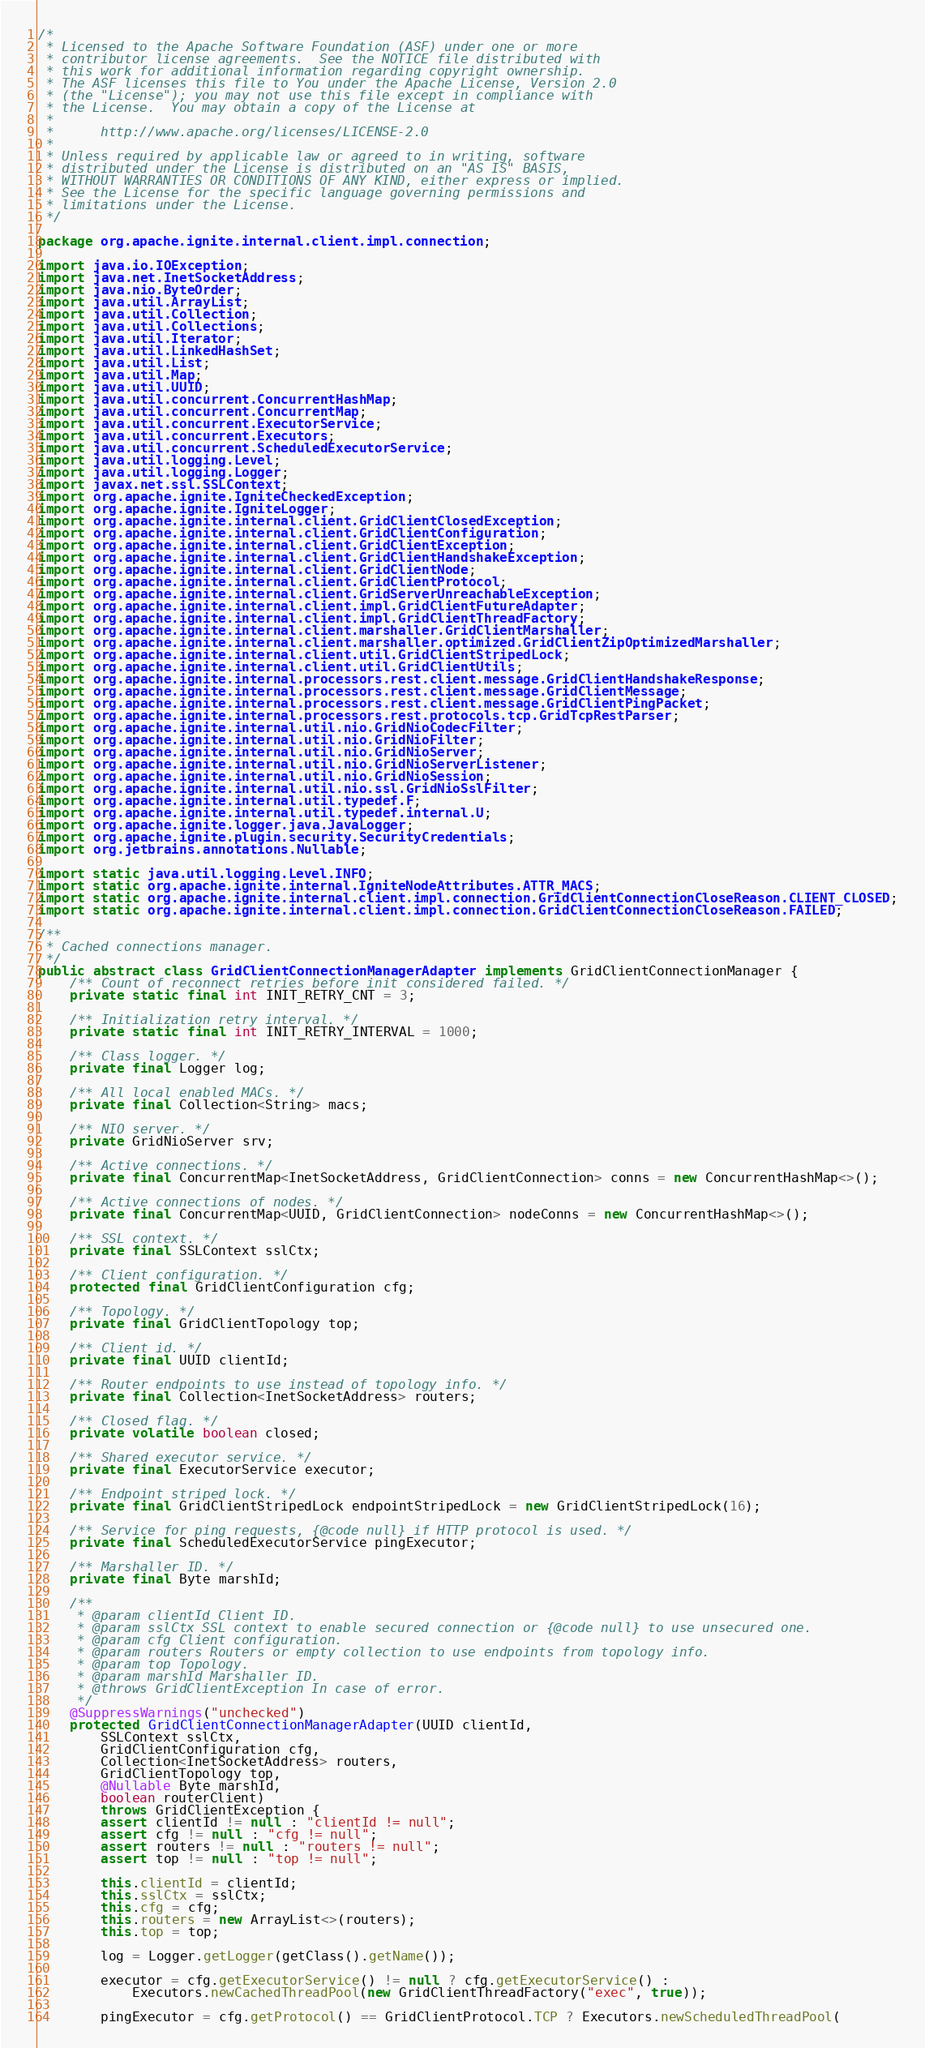<code> <loc_0><loc_0><loc_500><loc_500><_Java_>/*
 * Licensed to the Apache Software Foundation (ASF) under one or more
 * contributor license agreements.  See the NOTICE file distributed with
 * this work for additional information regarding copyright ownership.
 * The ASF licenses this file to You under the Apache License, Version 2.0
 * (the "License"); you may not use this file except in compliance with
 * the License.  You may obtain a copy of the License at
 *
 *      http://www.apache.org/licenses/LICENSE-2.0
 *
 * Unless required by applicable law or agreed to in writing, software
 * distributed under the License is distributed on an "AS IS" BASIS,
 * WITHOUT WARRANTIES OR CONDITIONS OF ANY KIND, either express or implied.
 * See the License for the specific language governing permissions and
 * limitations under the License.
 */

package org.apache.ignite.internal.client.impl.connection;

import java.io.IOException;
import java.net.InetSocketAddress;
import java.nio.ByteOrder;
import java.util.ArrayList;
import java.util.Collection;
import java.util.Collections;
import java.util.Iterator;
import java.util.LinkedHashSet;
import java.util.List;
import java.util.Map;
import java.util.UUID;
import java.util.concurrent.ConcurrentHashMap;
import java.util.concurrent.ConcurrentMap;
import java.util.concurrent.ExecutorService;
import java.util.concurrent.Executors;
import java.util.concurrent.ScheduledExecutorService;
import java.util.logging.Level;
import java.util.logging.Logger;
import javax.net.ssl.SSLContext;
import org.apache.ignite.IgniteCheckedException;
import org.apache.ignite.IgniteLogger;
import org.apache.ignite.internal.client.GridClientClosedException;
import org.apache.ignite.internal.client.GridClientConfiguration;
import org.apache.ignite.internal.client.GridClientException;
import org.apache.ignite.internal.client.GridClientHandshakeException;
import org.apache.ignite.internal.client.GridClientNode;
import org.apache.ignite.internal.client.GridClientProtocol;
import org.apache.ignite.internal.client.GridServerUnreachableException;
import org.apache.ignite.internal.client.impl.GridClientFutureAdapter;
import org.apache.ignite.internal.client.impl.GridClientThreadFactory;
import org.apache.ignite.internal.client.marshaller.GridClientMarshaller;
import org.apache.ignite.internal.client.marshaller.optimized.GridClientZipOptimizedMarshaller;
import org.apache.ignite.internal.client.util.GridClientStripedLock;
import org.apache.ignite.internal.client.util.GridClientUtils;
import org.apache.ignite.internal.processors.rest.client.message.GridClientHandshakeResponse;
import org.apache.ignite.internal.processors.rest.client.message.GridClientMessage;
import org.apache.ignite.internal.processors.rest.client.message.GridClientPingPacket;
import org.apache.ignite.internal.processors.rest.protocols.tcp.GridTcpRestParser;
import org.apache.ignite.internal.util.nio.GridNioCodecFilter;
import org.apache.ignite.internal.util.nio.GridNioFilter;
import org.apache.ignite.internal.util.nio.GridNioServer;
import org.apache.ignite.internal.util.nio.GridNioServerListener;
import org.apache.ignite.internal.util.nio.GridNioSession;
import org.apache.ignite.internal.util.nio.ssl.GridNioSslFilter;
import org.apache.ignite.internal.util.typedef.F;
import org.apache.ignite.internal.util.typedef.internal.U;
import org.apache.ignite.logger.java.JavaLogger;
import org.apache.ignite.plugin.security.SecurityCredentials;
import org.jetbrains.annotations.Nullable;

import static java.util.logging.Level.INFO;
import static org.apache.ignite.internal.IgniteNodeAttributes.ATTR_MACS;
import static org.apache.ignite.internal.client.impl.connection.GridClientConnectionCloseReason.CLIENT_CLOSED;
import static org.apache.ignite.internal.client.impl.connection.GridClientConnectionCloseReason.FAILED;

/**
 * Cached connections manager.
 */
public abstract class GridClientConnectionManagerAdapter implements GridClientConnectionManager {
    /** Count of reconnect retries before init considered failed. */
    private static final int INIT_RETRY_CNT = 3;

    /** Initialization retry interval. */
    private static final int INIT_RETRY_INTERVAL = 1000;

    /** Class logger. */
    private final Logger log;

    /** All local enabled MACs. */
    private final Collection<String> macs;

    /** NIO server. */
    private GridNioServer srv;

    /** Active connections. */
    private final ConcurrentMap<InetSocketAddress, GridClientConnection> conns = new ConcurrentHashMap<>();

    /** Active connections of nodes. */
    private final ConcurrentMap<UUID, GridClientConnection> nodeConns = new ConcurrentHashMap<>();

    /** SSL context. */
    private final SSLContext sslCtx;

    /** Client configuration. */
    protected final GridClientConfiguration cfg;

    /** Topology. */
    private final GridClientTopology top;

    /** Client id. */
    private final UUID clientId;

    /** Router endpoints to use instead of topology info. */
    private final Collection<InetSocketAddress> routers;

    /** Closed flag. */
    private volatile boolean closed;

    /** Shared executor service. */
    private final ExecutorService executor;

    /** Endpoint striped lock. */
    private final GridClientStripedLock endpointStripedLock = new GridClientStripedLock(16);

    /** Service for ping requests, {@code null} if HTTP protocol is used. */
    private final ScheduledExecutorService pingExecutor;

    /** Marshaller ID. */
    private final Byte marshId;

    /**
     * @param clientId Client ID.
     * @param sslCtx SSL context to enable secured connection or {@code null} to use unsecured one.
     * @param cfg Client configuration.
     * @param routers Routers or empty collection to use endpoints from topology info.
     * @param top Topology.
     * @param marshId Marshaller ID.
     * @throws GridClientException In case of error.
     */
    @SuppressWarnings("unchecked")
    protected GridClientConnectionManagerAdapter(UUID clientId,
        SSLContext sslCtx,
        GridClientConfiguration cfg,
        Collection<InetSocketAddress> routers,
        GridClientTopology top,
        @Nullable Byte marshId,
        boolean routerClient)
        throws GridClientException {
        assert clientId != null : "clientId != null";
        assert cfg != null : "cfg != null";
        assert routers != null : "routers != null";
        assert top != null : "top != null";

        this.clientId = clientId;
        this.sslCtx = sslCtx;
        this.cfg = cfg;
        this.routers = new ArrayList<>(routers);
        this.top = top;

        log = Logger.getLogger(getClass().getName());

        executor = cfg.getExecutorService() != null ? cfg.getExecutorService() :
            Executors.newCachedThreadPool(new GridClientThreadFactory("exec", true));

        pingExecutor = cfg.getProtocol() == GridClientProtocol.TCP ? Executors.newScheduledThreadPool(</code> 